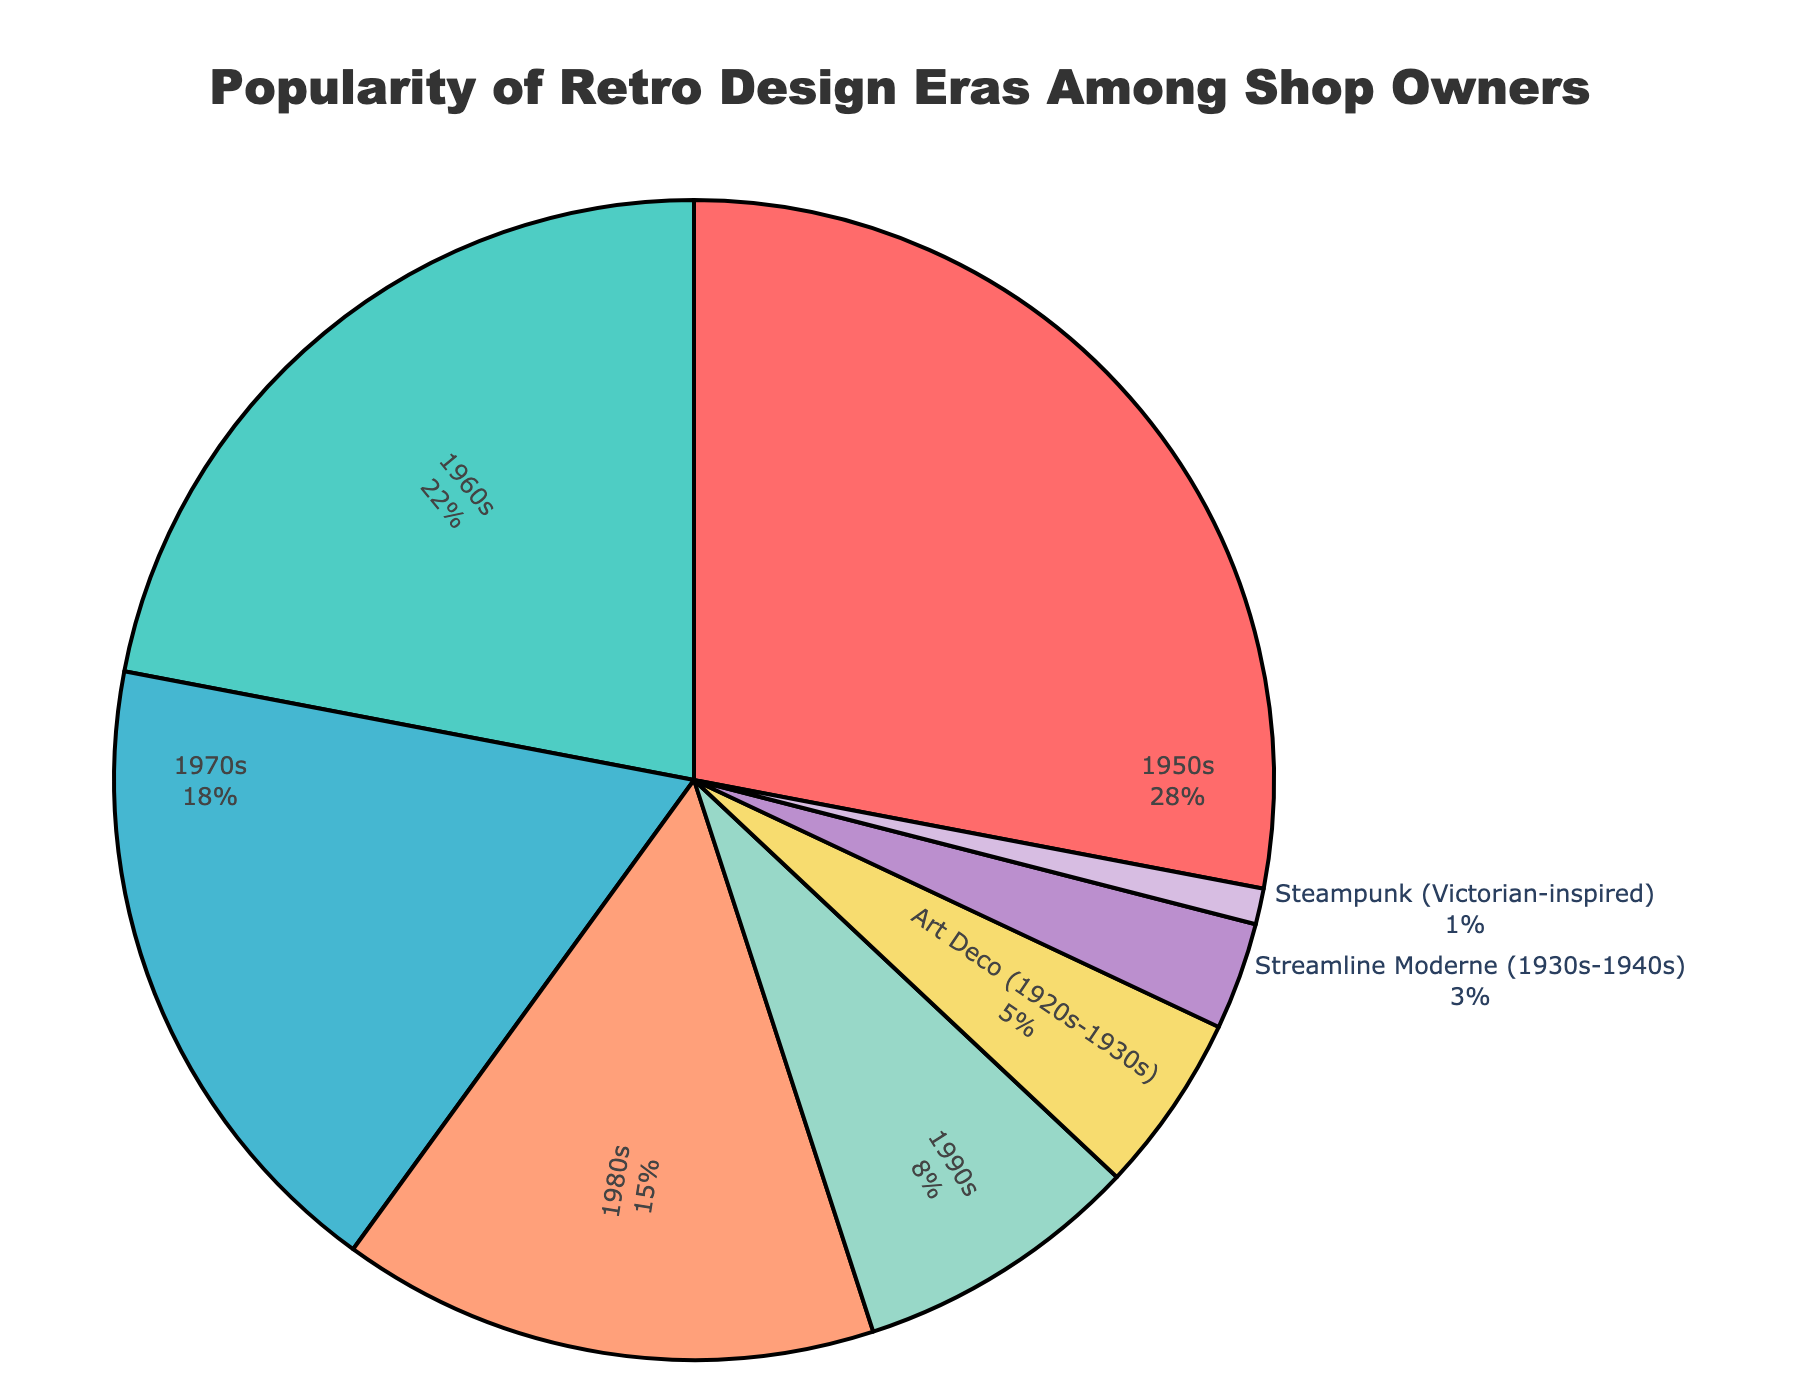What era is the most popular among shop owners? The figure shows that the 1950s era takes up the largest portion of the pie chart with 28%. This indicates that it is the most popular retro design era among shop owners.
Answer: 1950s Which era is least popular among shop owners? The smallest slice of the pie chart belongs to the Steampunk era, making it the least popular one with a percentage of 1%.
Answer: Steampunk What is the combined popularity of the 1970s and 1980s eras? According to the chart, the popularity of the 1970s era is 18%, and the 1980s era is 15%. Summing these two percentages results in a combined popularity of 33%.
Answer: 33% Which era has a higher popularity: Art Deco (1920s-1930s) or Streamline Moderne (1930s-1940s)? The Art Deco era is represented by a slice corresponding to 5% of the pie chart, while the Streamline Moderne era is represented by a smaller slice corresponding to 3%. Therefore, Art Deco is more popular than Streamline Moderne.
Answer: Art Deco (1920s-1930s) What percentage of shop owners prefer designs from the 1950s, 1960s, and 1970s altogether? The 1950s era accounts for 28%, the 1960s for 22%, and the 1970s for 18%. Adding these percentages: 28% + 22% + 18% = 68%. So, 68% of shop owners prefer designs from these three eras altogether.
Answer: 68% How does the popularity of the 1990s era compare with the 1960s era? The 1990s era has a popularity of 8%, and the 1960s era has a popularity of 22%. Therefore, the 1960s era is 14% more popular than the 1990s era.
Answer: The 1960s era is more popular What is the total percentage of shop owners favoring pre-1950s design eras (including Art Deco and Streamline Moderne)? The Art Deco era has 5%, and the Streamline Moderne era has 3%. Summing these gives us 5% + 3% = 8%. Thus, 8% of shop owners prefer pre-1950s design eras.
Answer: 8% Which two eras combined have a total popularity closest to that of the 1950s era? The 1950s era has a popularity of 28%. The combined popularity closest to this can be achieved using the 1960s (22%) and 1990s (8%) eras, adding to 22% + 8% = 30%.
Answer: 1960s and 1990s How much more popular is the 1980s era compared to the Streamline Moderne era? The 1980s era has a percentage of 15%, and the Streamline Moderne era has 3%. The difference in popularity is 15% - 3% = 12%.
Answer: 12% 